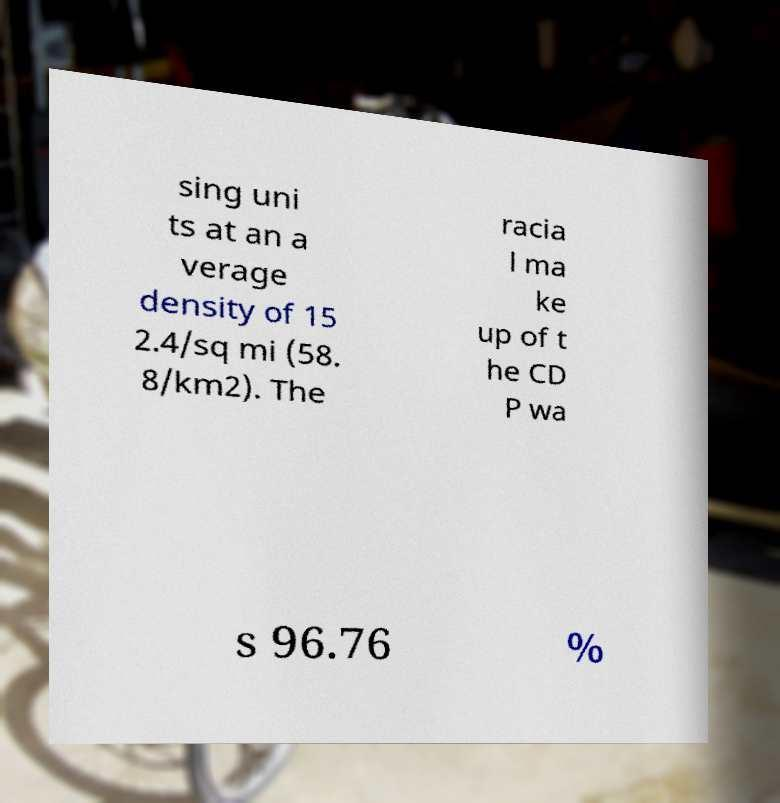Could you extract and type out the text from this image? sing uni ts at an a verage density of 15 2.4/sq mi (58. 8/km2). The racia l ma ke up of t he CD P wa s 96.76 % 